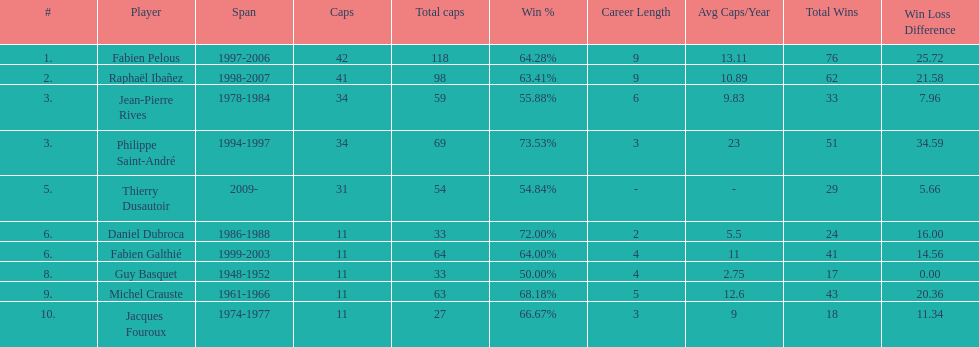How many players have spans above three years? 6. 